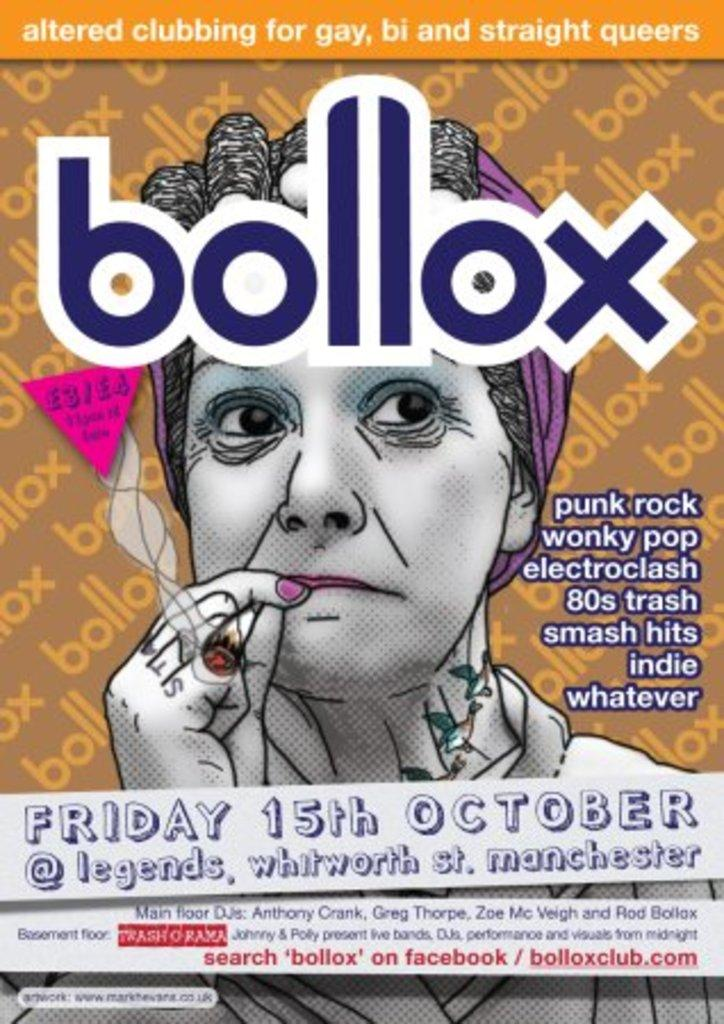Provide a one-sentence caption for the provided image. A flyer for a club in Manchester called Bollox. 